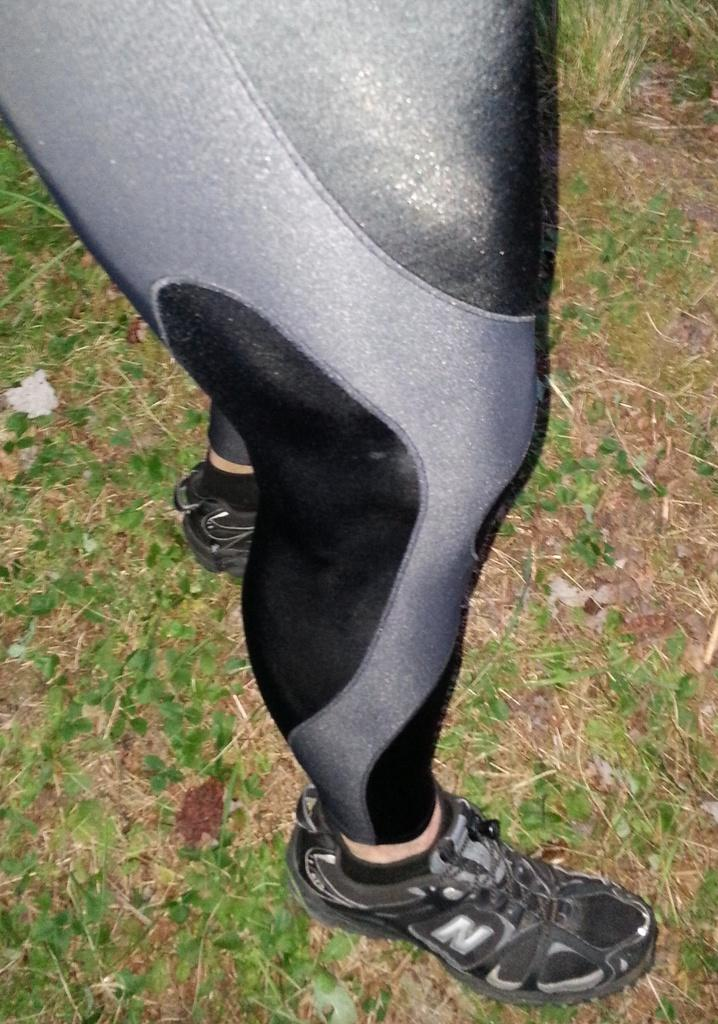Who is present in the image? There is a man in the image. What is the man standing on? The man is standing on grassy land. What type of shoes is the man wearing? The man is wearing black shoes. What color is the man's dress? The man is wearing a black-grey color dress. What letter does the man's voice sound like in the image? The man's voice cannot be heard in the image, and therefore it cannot be compared to a letter. 